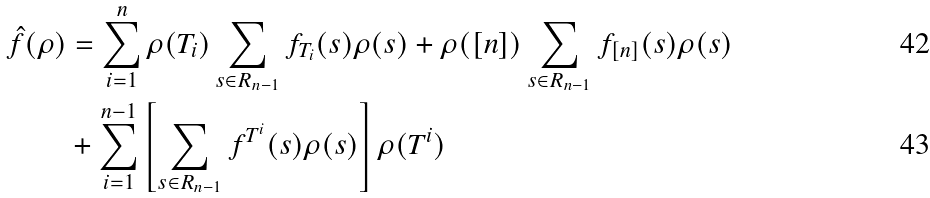Convert formula to latex. <formula><loc_0><loc_0><loc_500><loc_500>\hat { f } ( \rho ) & = \sum _ { i = 1 } ^ { n } \rho ( T _ { i } ) \sum _ { s \in R _ { n - 1 } } f _ { T _ { i } } ( s ) \rho ( s ) + \rho ( [ n ] ) \sum _ { s \in R _ { n - 1 } } f _ { [ n ] } ( s ) \rho ( s ) \\ & + \sum _ { i = 1 } ^ { n - 1 } \left [ \sum _ { s \in R _ { n - 1 } } f ^ { T ^ { i } } ( s ) \rho ( s ) \right ] \rho ( T ^ { i } )</formula> 